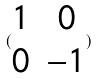Convert formula to latex. <formula><loc_0><loc_0><loc_500><loc_500>( \begin{matrix} 1 & 0 \\ 0 & - 1 \end{matrix} )</formula> 